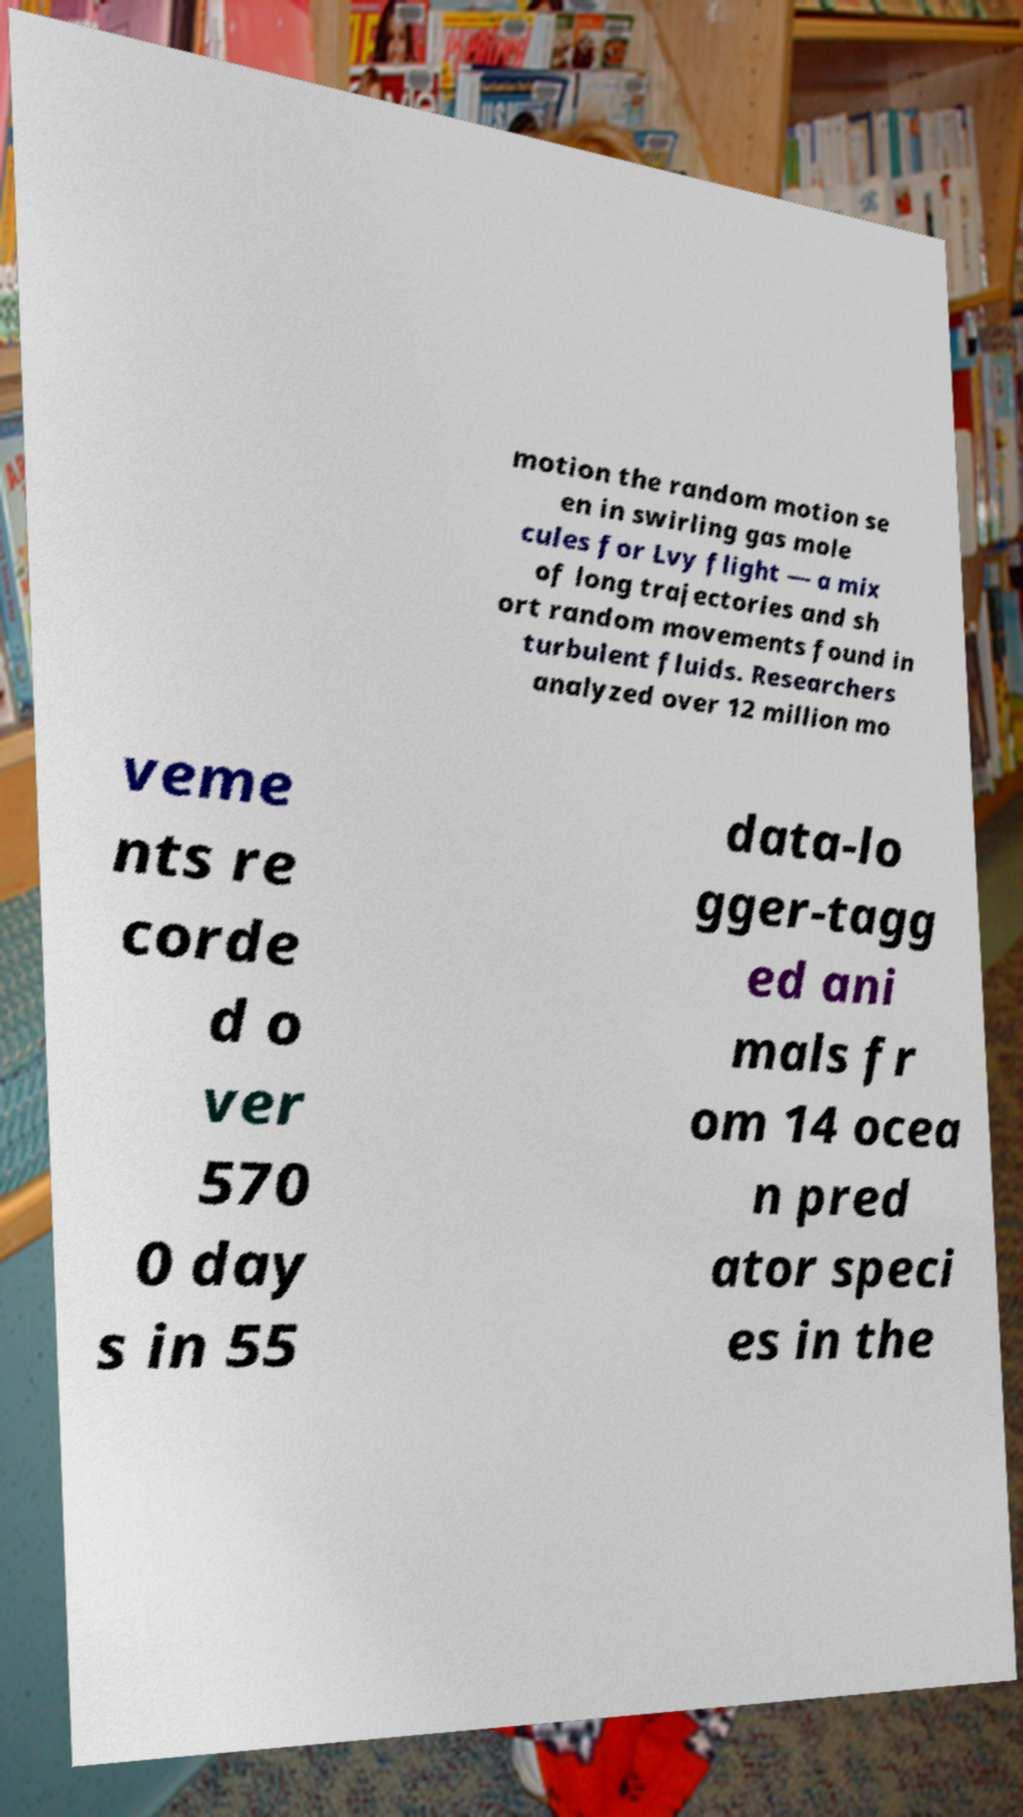There's text embedded in this image that I need extracted. Can you transcribe it verbatim? motion the random motion se en in swirling gas mole cules for Lvy flight — a mix of long trajectories and sh ort random movements found in turbulent fluids. Researchers analyzed over 12 million mo veme nts re corde d o ver 570 0 day s in 55 data-lo gger-tagg ed ani mals fr om 14 ocea n pred ator speci es in the 